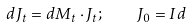Convert formula to latex. <formula><loc_0><loc_0><loc_500><loc_500>d J _ { t } = d M _ { t } \cdot J _ { t } ; \quad J _ { 0 } = I d</formula> 